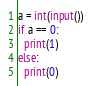Convert code to text. <code><loc_0><loc_0><loc_500><loc_500><_Python_>a = int(input())
if a == 0:
  print(1)
else:
  print(0)</code> 